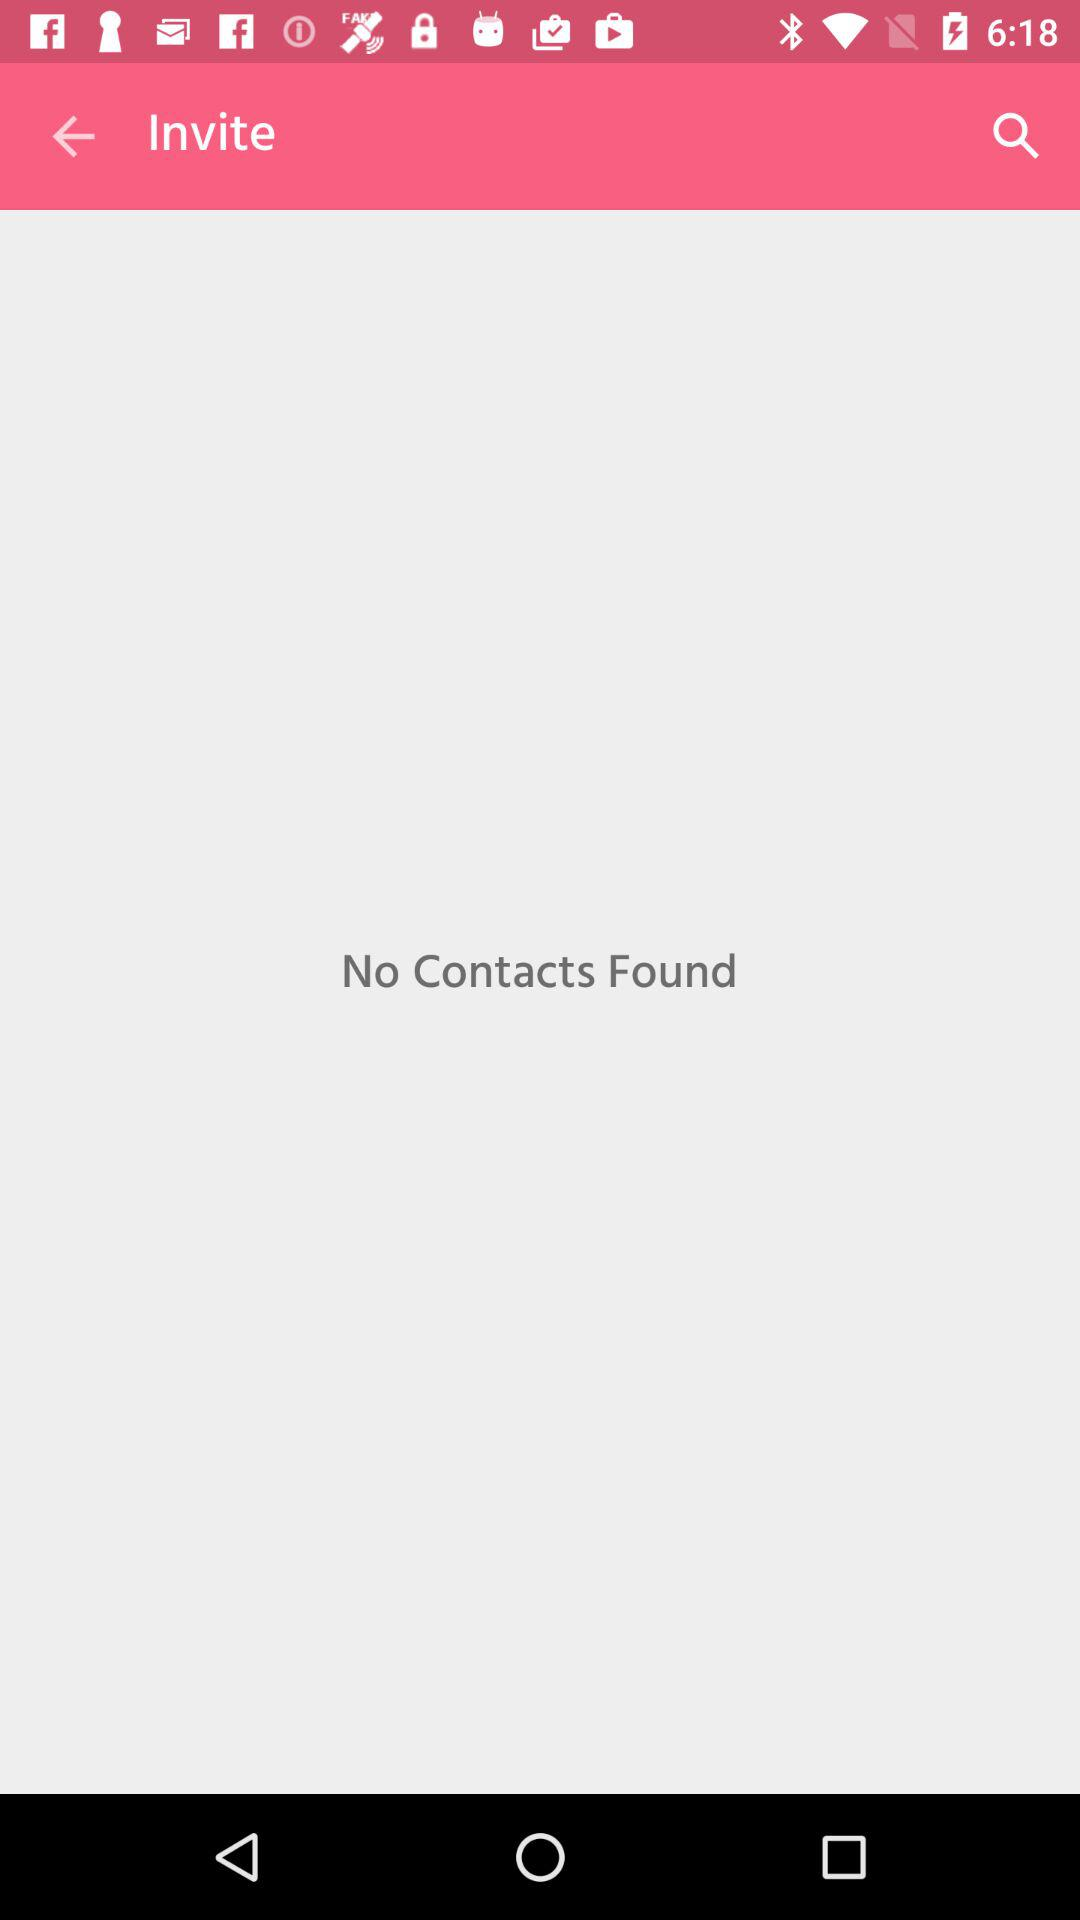Are there any contacts found? There were no contacts found. 